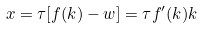Convert formula to latex. <formula><loc_0><loc_0><loc_500><loc_500>x = \tau [ f ( k ) - w ] = \tau f ^ { \prime } ( k ) k</formula> 